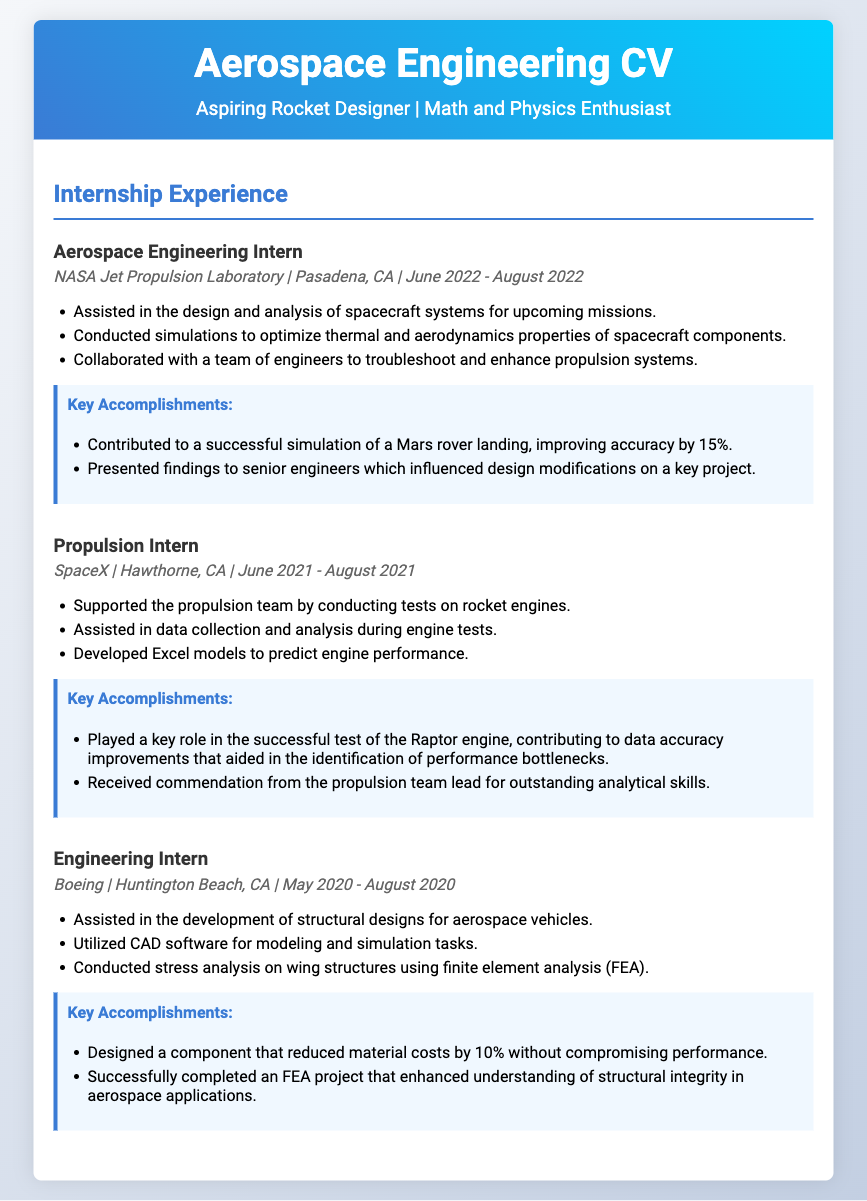What is the title of the CV? The title of the CV is presented prominently in the header section, indicating the focus on aerospace engineering.
Answer: Aerospace Engineering CV What company did the Aerospace Engineering Intern work for? The company name is listed under the internship details for the Aerospace Engineering Intern role.
Answer: NASA Jet Propulsion Laboratory What were the dates for the Propulsion Intern role? The dates are mentioned in a specific format in the internship details section.
Answer: June 2021 - August 2021 How much did the design component reduce material costs by at Boeing? The percentage is noted as a key accomplishment under the Engineering Intern experience.
Answer: 10% Which simulation improved accuracy by 15%? The specific project is identified in the accomplishments of the Aerospace Engineering Intern section.
Answer: Mars rover landing What software was utilized for modeling and simulation tasks at Boeing? This information is provided in the descriptions for the Engineering Intern responsibilities.
Answer: CAD software What key role did the intern play in the Raptor engine test? The significant contribution is highlighted in the accomplishments section under the Propulsion Intern role.
Answer: Data accuracy improvements Which internship involved conducting stress analysis using finite element analysis? This specific duty is mentioned under the responsibilities for the Engineering Intern position.
Answer: Engineering Intern at Boeing 